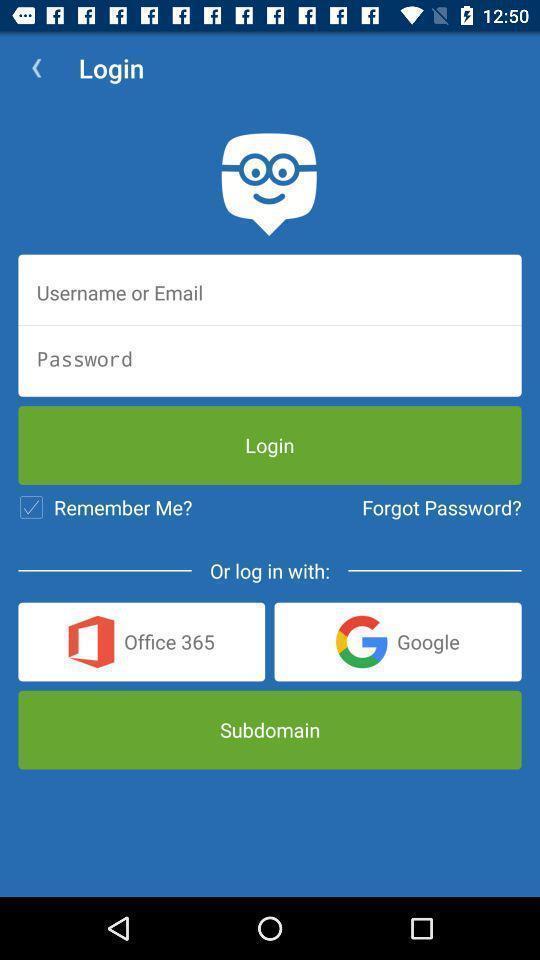Summarize the main components in this picture. Welcome and log-in page for an application. 